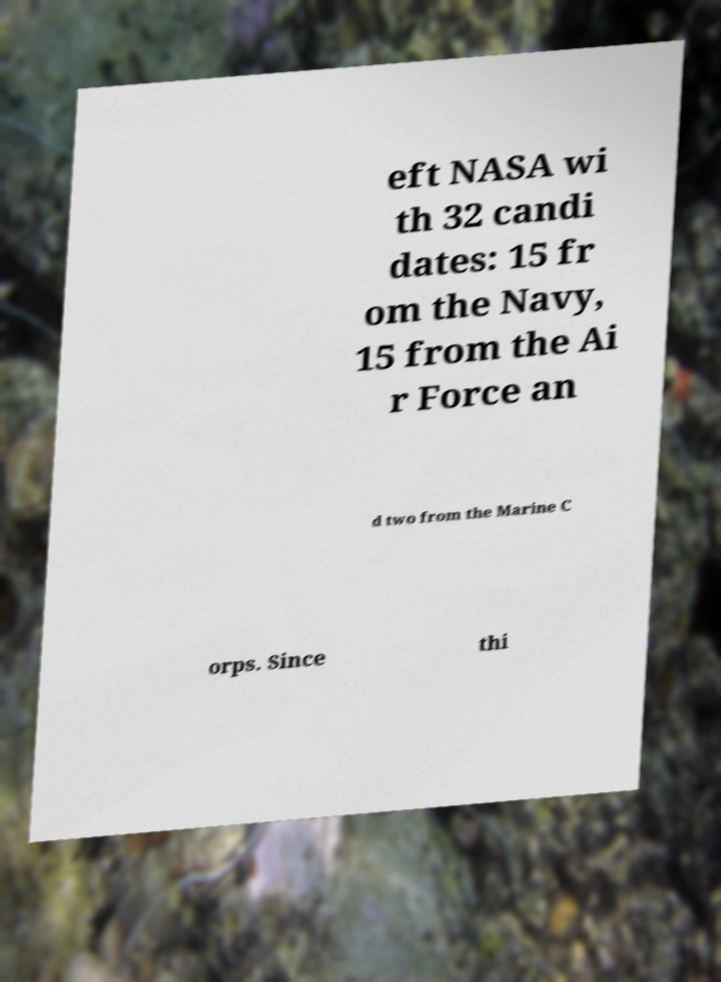Please identify and transcribe the text found in this image. eft NASA wi th 32 candi dates: 15 fr om the Navy, 15 from the Ai r Force an d two from the Marine C orps. Since thi 